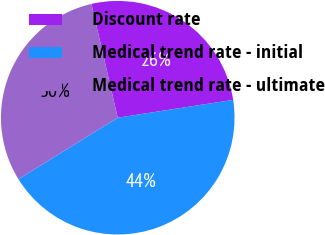Convert chart. <chart><loc_0><loc_0><loc_500><loc_500><pie_chart><fcel>Discount rate<fcel>Medical trend rate - initial<fcel>Medical trend rate - ultimate<nl><fcel>26.17%<fcel>43.62%<fcel>30.2%<nl></chart> 